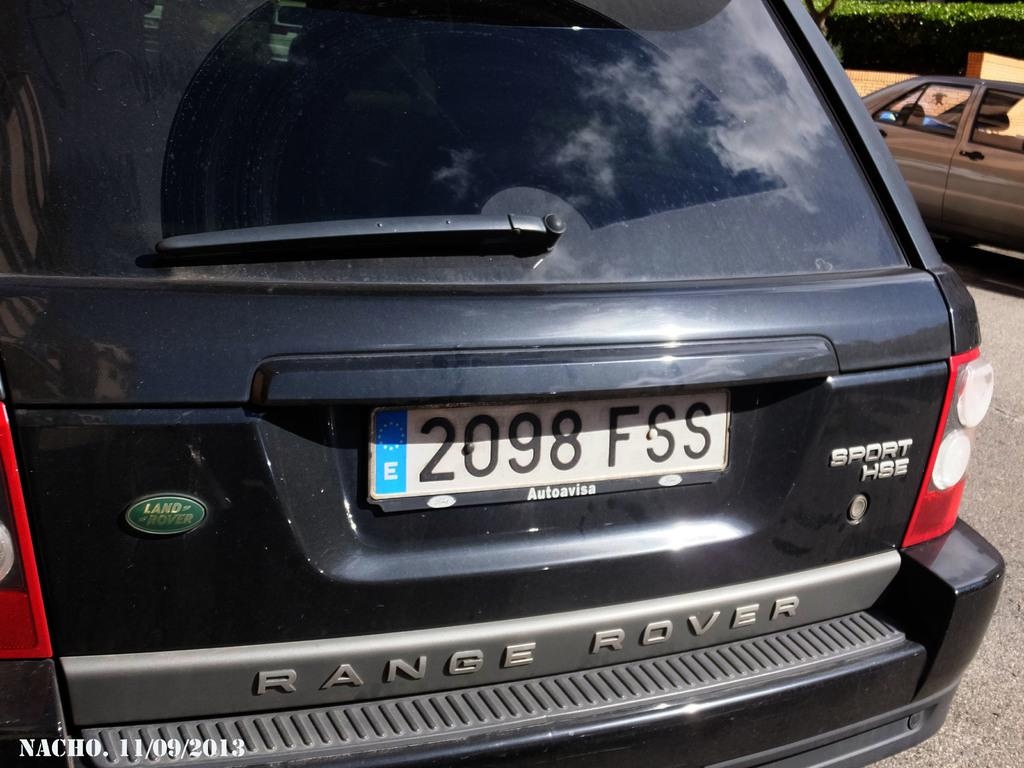<image>
Share a concise interpretation of the image provided. A black SUV says Range Rover on the back. 